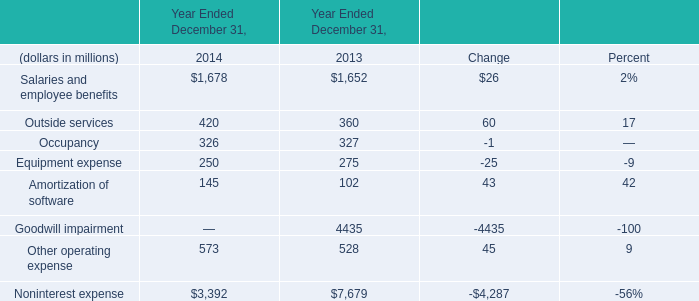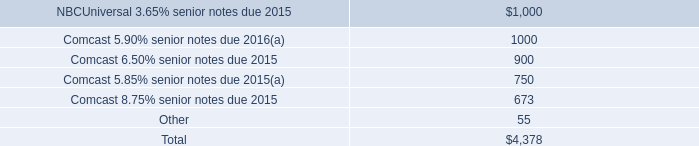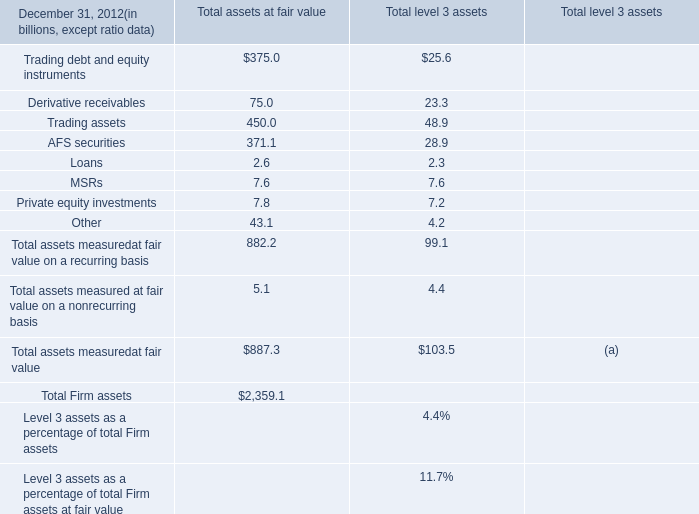What is the percentage of Occupancy in relation to the total in 2014? 
Computations: (326 / 3392)
Answer: 0.09611. 